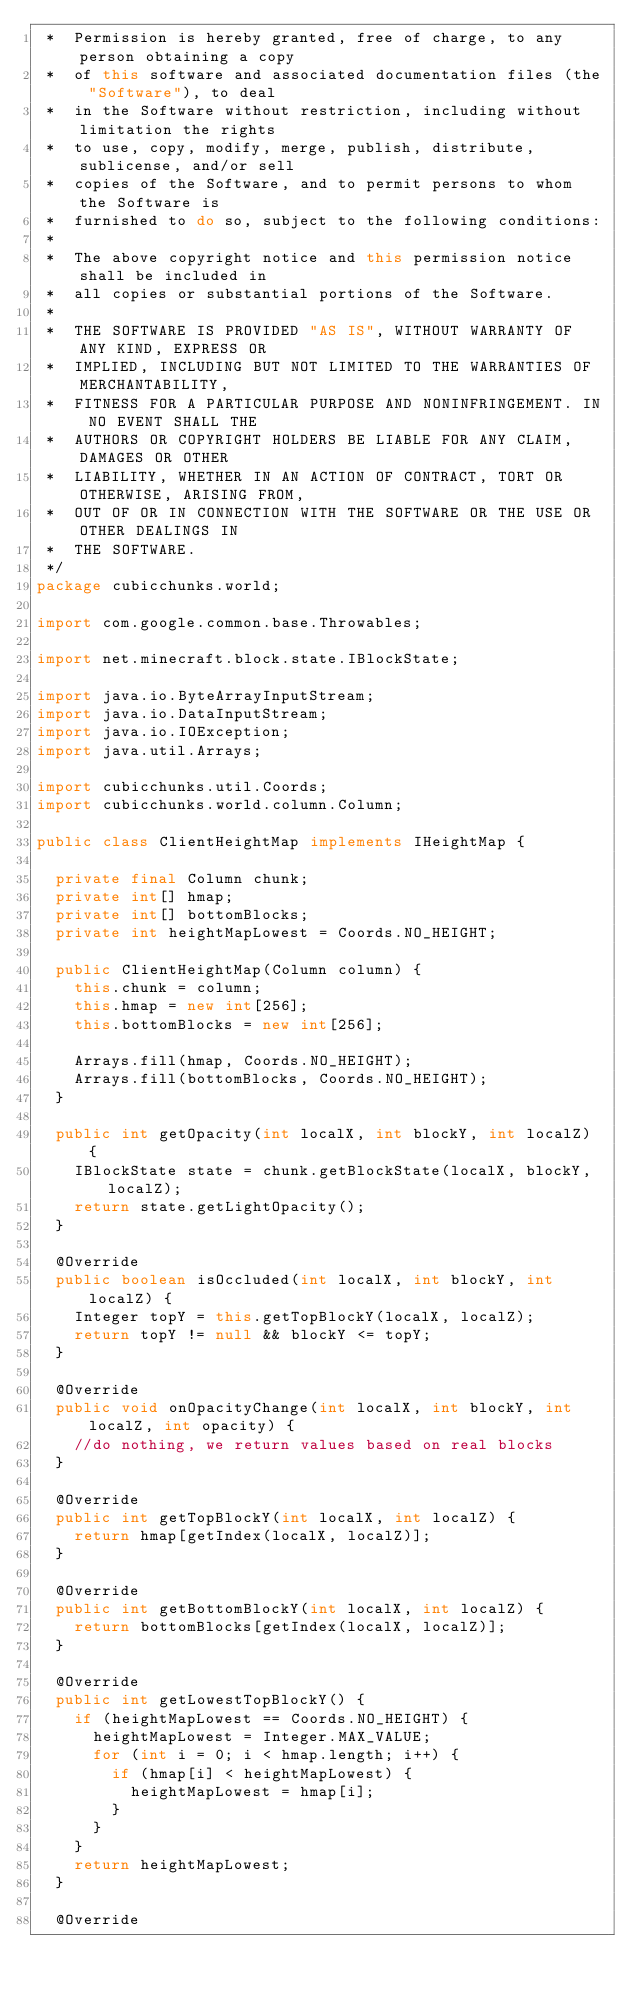Convert code to text. <code><loc_0><loc_0><loc_500><loc_500><_Java_> *  Permission is hereby granted, free of charge, to any person obtaining a copy
 *  of this software and associated documentation files (the "Software"), to deal
 *  in the Software without restriction, including without limitation the rights
 *  to use, copy, modify, merge, publish, distribute, sublicense, and/or sell
 *  copies of the Software, and to permit persons to whom the Software is
 *  furnished to do so, subject to the following conditions:
 *
 *  The above copyright notice and this permission notice shall be included in
 *  all copies or substantial portions of the Software.
 *
 *  THE SOFTWARE IS PROVIDED "AS IS", WITHOUT WARRANTY OF ANY KIND, EXPRESS OR
 *  IMPLIED, INCLUDING BUT NOT LIMITED TO THE WARRANTIES OF MERCHANTABILITY,
 *  FITNESS FOR A PARTICULAR PURPOSE AND NONINFRINGEMENT. IN NO EVENT SHALL THE
 *  AUTHORS OR COPYRIGHT HOLDERS BE LIABLE FOR ANY CLAIM, DAMAGES OR OTHER
 *  LIABILITY, WHETHER IN AN ACTION OF CONTRACT, TORT OR OTHERWISE, ARISING FROM,
 *  OUT OF OR IN CONNECTION WITH THE SOFTWARE OR THE USE OR OTHER DEALINGS IN
 *  THE SOFTWARE.
 */
package cubicchunks.world;

import com.google.common.base.Throwables;

import net.minecraft.block.state.IBlockState;

import java.io.ByteArrayInputStream;
import java.io.DataInputStream;
import java.io.IOException;
import java.util.Arrays;

import cubicchunks.util.Coords;
import cubicchunks.world.column.Column;

public class ClientHeightMap implements IHeightMap {

	private final Column chunk;
	private int[] hmap;
	private int[] bottomBlocks;
	private int heightMapLowest = Coords.NO_HEIGHT;

	public ClientHeightMap(Column column) {
		this.chunk = column;
		this.hmap = new int[256];
		this.bottomBlocks = new int[256];

		Arrays.fill(hmap, Coords.NO_HEIGHT);
		Arrays.fill(bottomBlocks, Coords.NO_HEIGHT);
	}

	public int getOpacity(int localX, int blockY, int localZ) {
		IBlockState state = chunk.getBlockState(localX, blockY, localZ);
		return state.getLightOpacity();
	}

	@Override
	public boolean isOccluded(int localX, int blockY, int localZ) {
		Integer topY = this.getTopBlockY(localX, localZ);
		return topY != null && blockY <= topY;
	}

	@Override
	public void onOpacityChange(int localX, int blockY, int localZ, int opacity) {
		//do nothing, we return values based on real blocks
	}

	@Override
	public int getTopBlockY(int localX, int localZ) {
		return hmap[getIndex(localX, localZ)];
	}

	@Override
	public int getBottomBlockY(int localX, int localZ) {
		return bottomBlocks[getIndex(localX, localZ)];
	}

	@Override
	public int getLowestTopBlockY() {
		if (heightMapLowest == Coords.NO_HEIGHT) {
			heightMapLowest = Integer.MAX_VALUE;
			for (int i = 0; i < hmap.length; i++) {
				if (hmap[i] < heightMapLowest) {
					heightMapLowest = hmap[i];
				}
			}
		}
		return heightMapLowest;
	}

	@Override</code> 